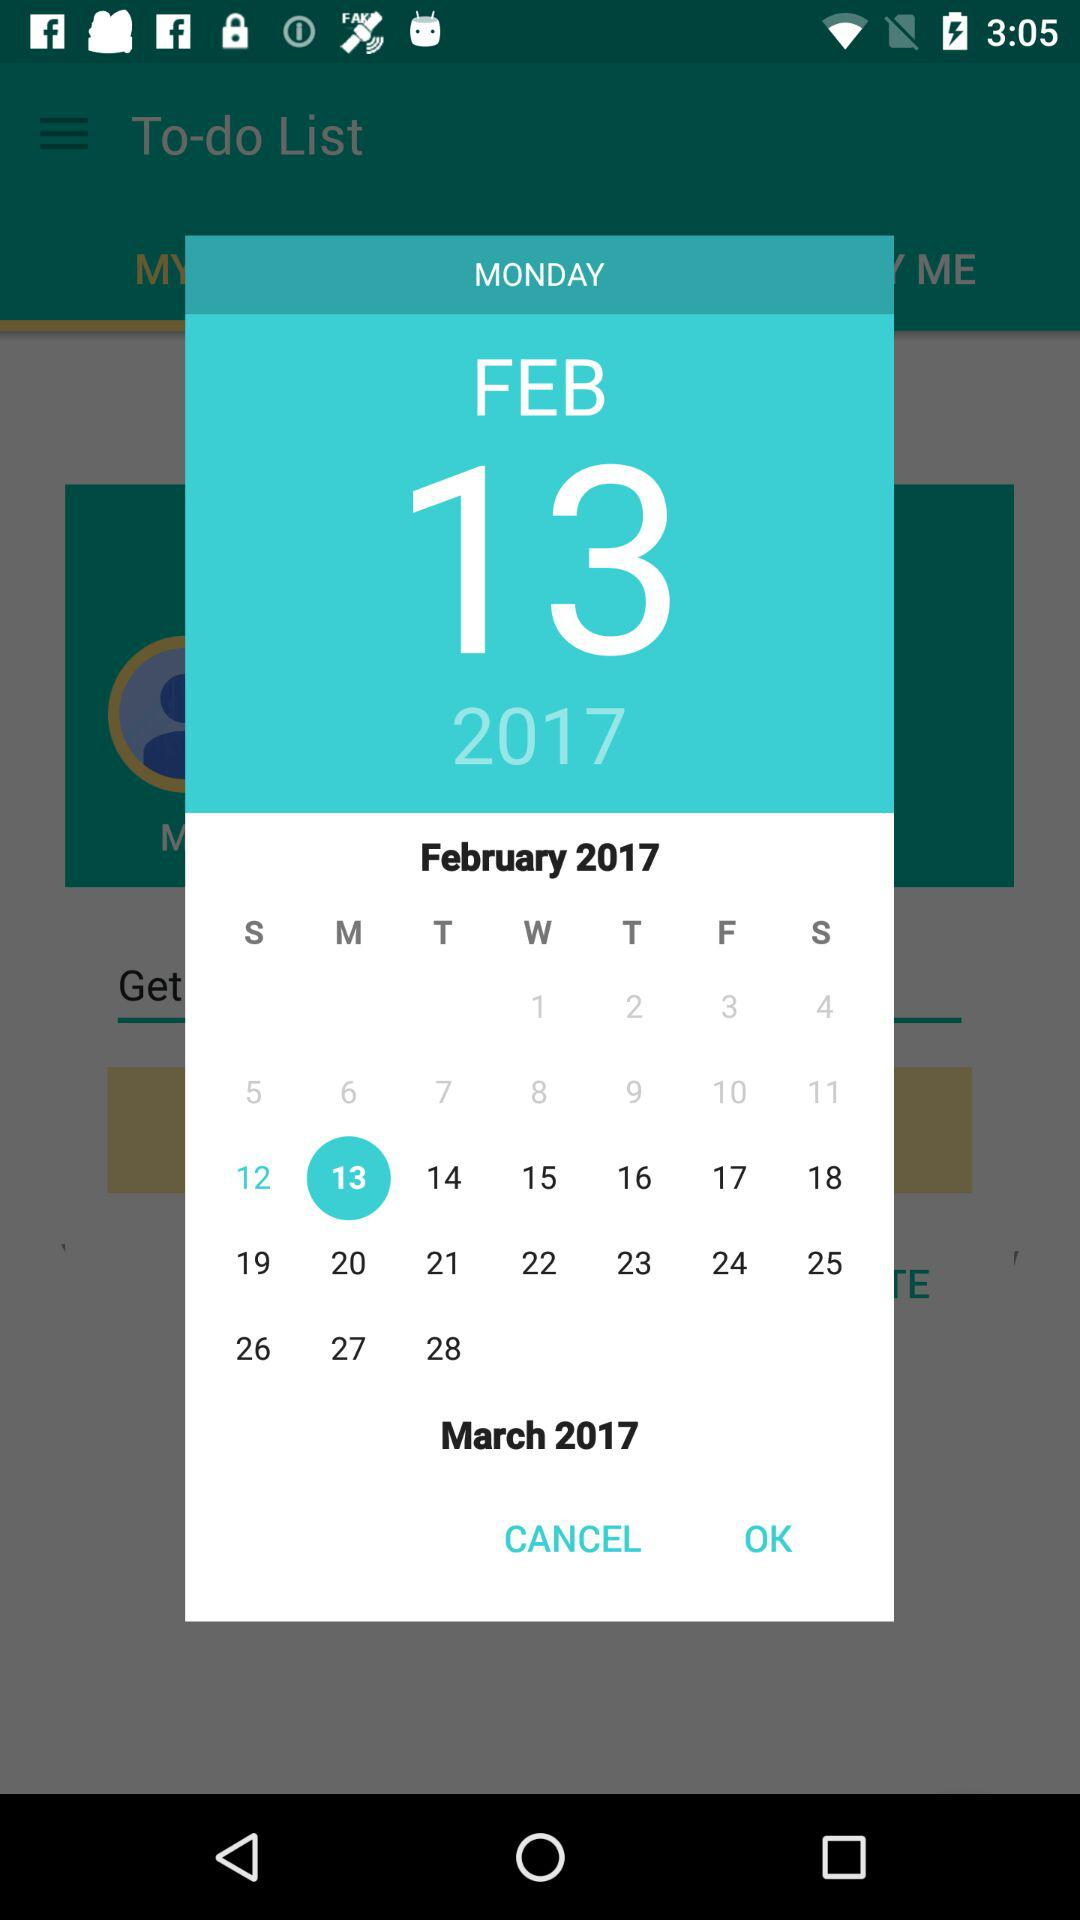What is the selected date? The selected date is Monday, February 13, 2017. 